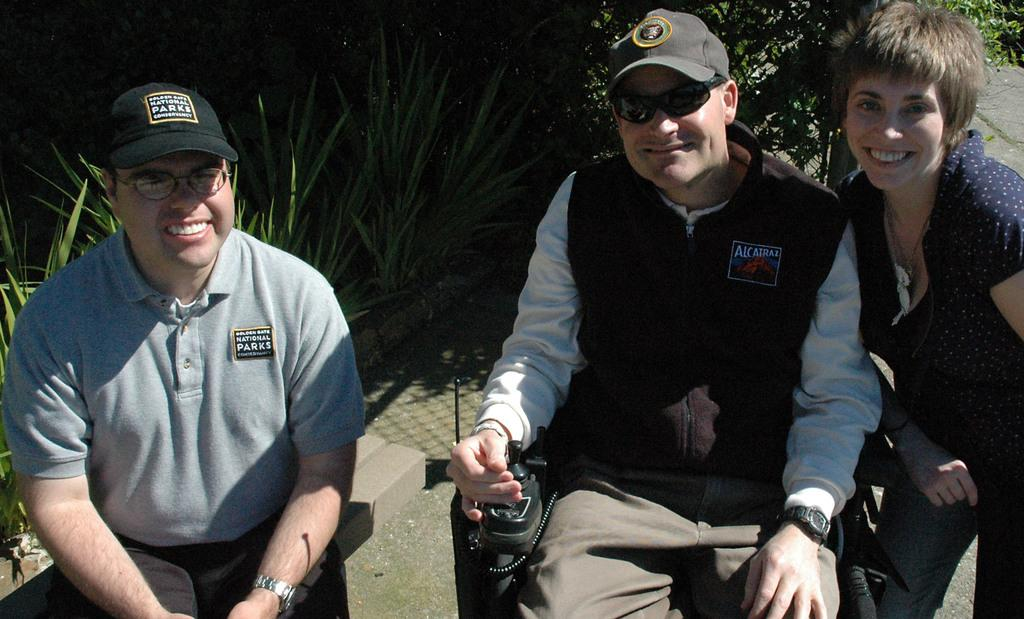How many people are in the image? There are three people in the image. What expressions do the people have in the image? All three people are smiling. What positions are the people in? Two of the people are sitting, while one is standing. What can be seen in the background of the image? There are plants visible in the background of the image. What type of meal is being served to the person wearing a crown in the image? There is no person wearing a crown or any meal being served in the image. 